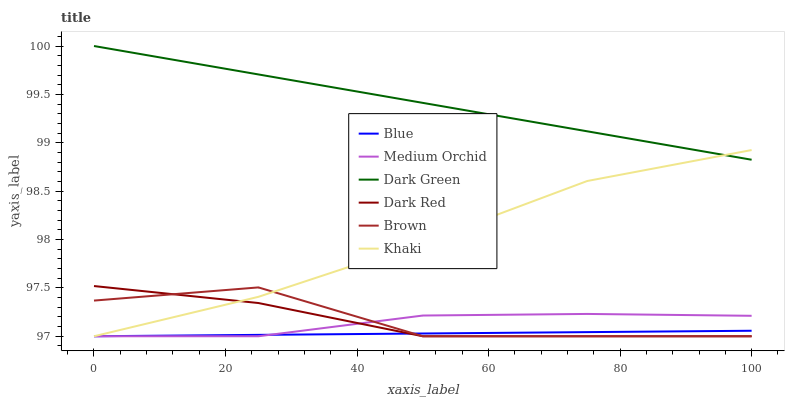Does Blue have the minimum area under the curve?
Answer yes or no. Yes. Does Dark Green have the maximum area under the curve?
Answer yes or no. Yes. Does Brown have the minimum area under the curve?
Answer yes or no. No. Does Brown have the maximum area under the curve?
Answer yes or no. No. Is Blue the smoothest?
Answer yes or no. Yes. Is Brown the roughest?
Answer yes or no. Yes. Is Khaki the smoothest?
Answer yes or no. No. Is Khaki the roughest?
Answer yes or no. No. Does Blue have the lowest value?
Answer yes or no. Yes. Does Dark Green have the lowest value?
Answer yes or no. No. Does Dark Green have the highest value?
Answer yes or no. Yes. Does Brown have the highest value?
Answer yes or no. No. Is Brown less than Dark Green?
Answer yes or no. Yes. Is Dark Green greater than Medium Orchid?
Answer yes or no. Yes. Does Medium Orchid intersect Blue?
Answer yes or no. Yes. Is Medium Orchid less than Blue?
Answer yes or no. No. Is Medium Orchid greater than Blue?
Answer yes or no. No. Does Brown intersect Dark Green?
Answer yes or no. No. 